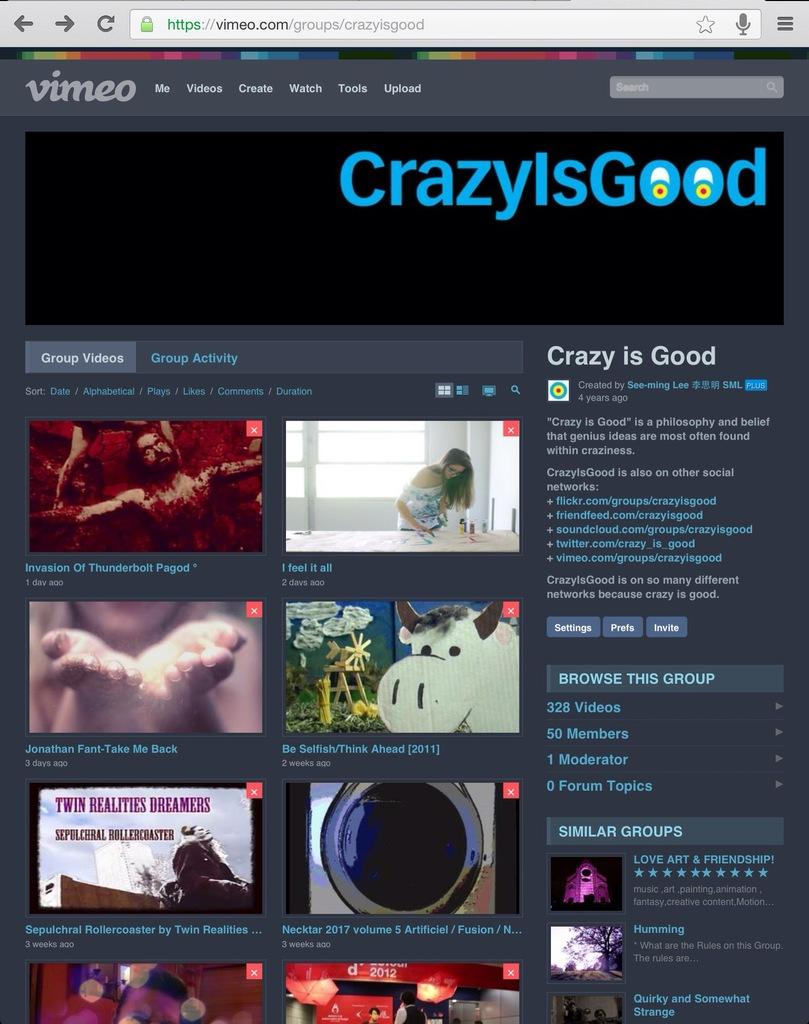Provide a one-sentence caption for the provided image. Vimeo's main page showing various videos that can be watched. 